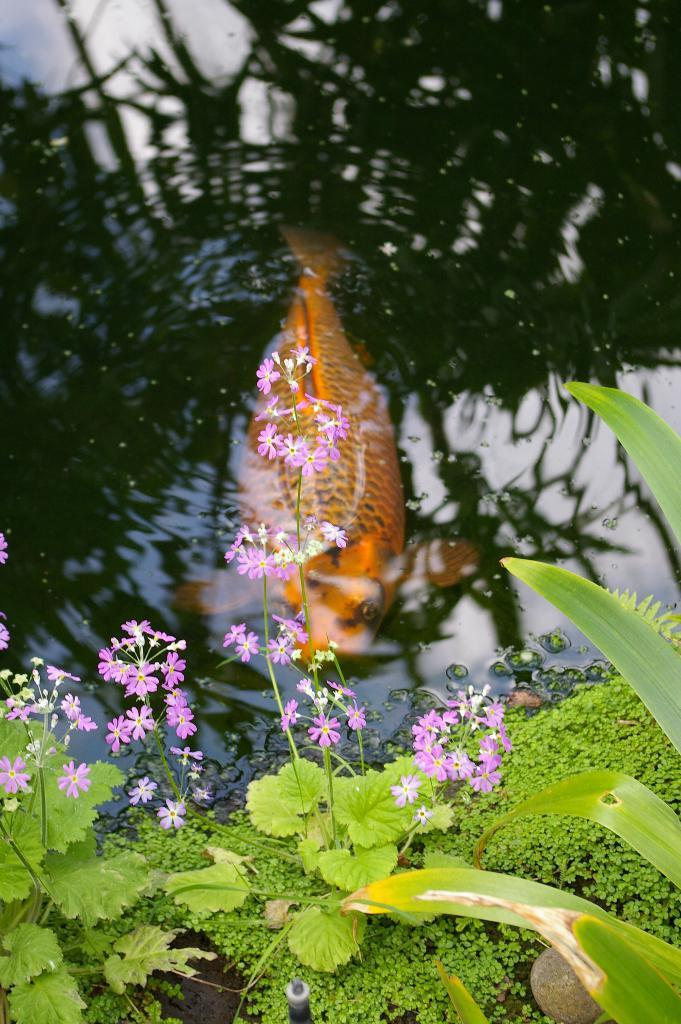What is in the water in the image? There is a fish in the water in the image. What other elements can be seen in the image? There are flowers, plants, a stone, and an unspecified object in the image. Can you describe the plants in the image? The plants in the image are not specified, but they are present. What is the unspecified object in the image? The unspecified object in the image is not described in detail, but it is present. What type of pleasure can be seen enjoying the flowers in the image? There is no indication of pleasure or any living being enjoying the flowers in the image. 